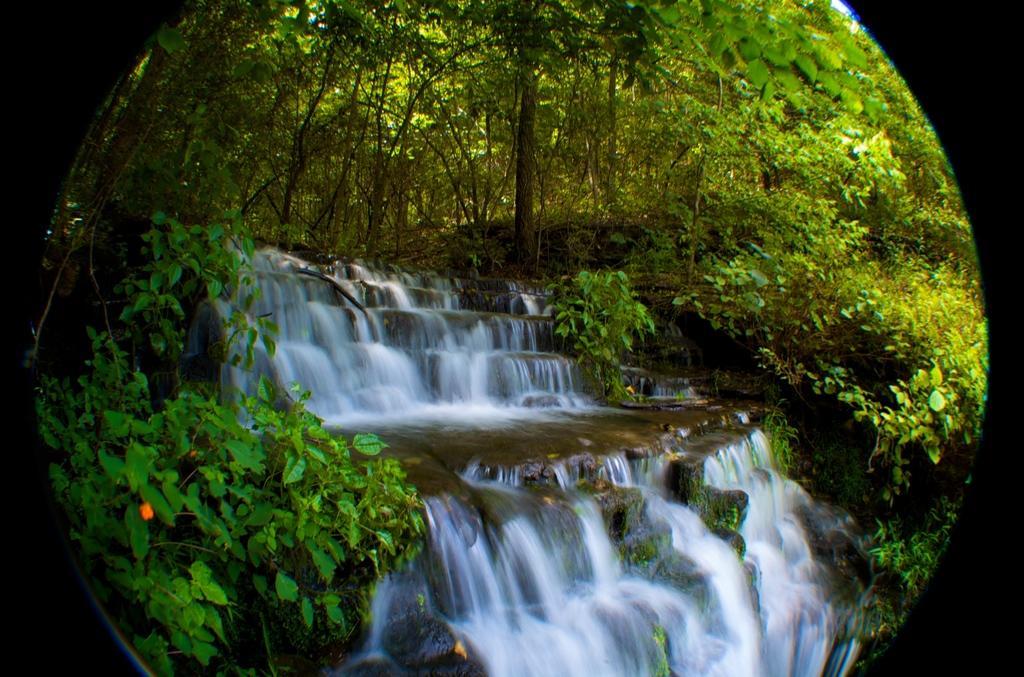In one or two sentences, can you explain what this image depicts? This picture seems to be an edited image with the borders and in the center we can see the running water and we can see the plants, trees and some rocks and some other objects. 